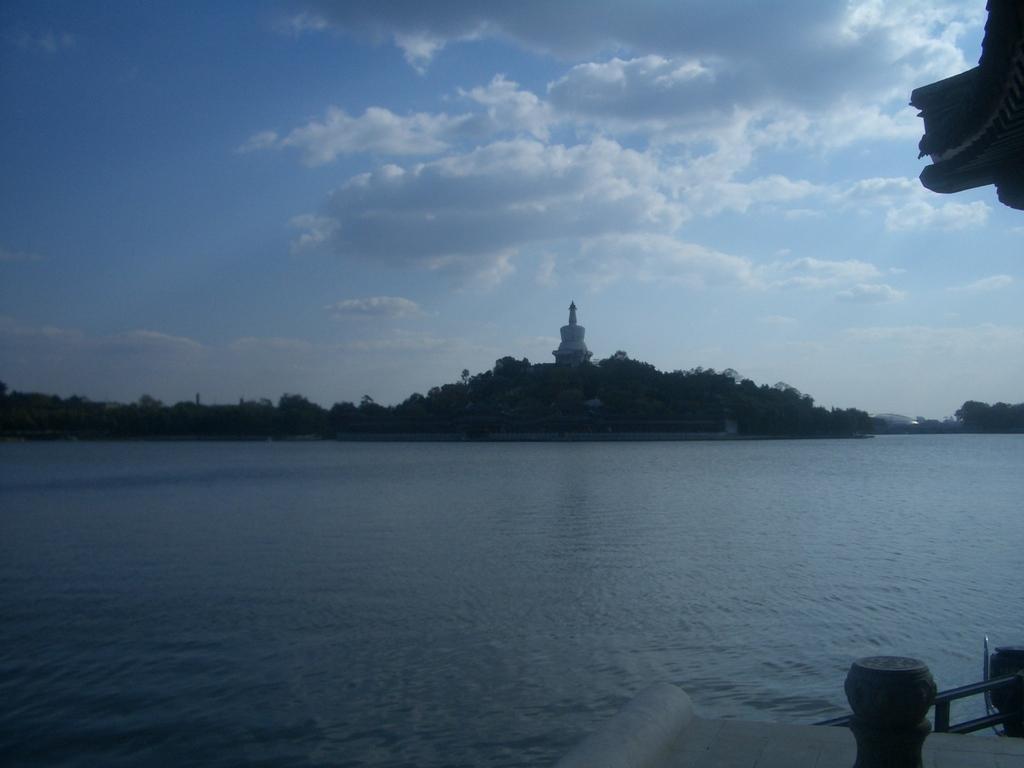How would you summarize this image in a sentence or two? In this picture we can see water, few metal rods and trees, in the background we can see a tower and clouds. 